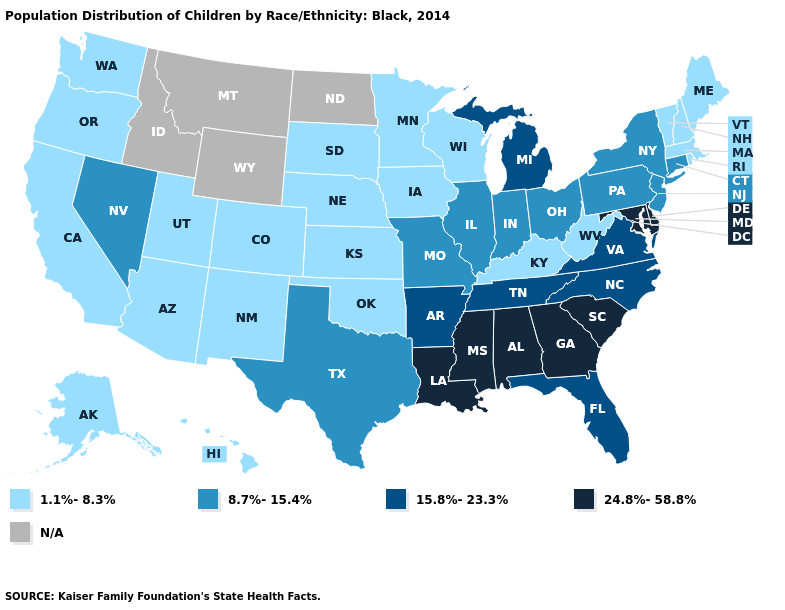Among the states that border Minnesota , which have the lowest value?
Be succinct. Iowa, South Dakota, Wisconsin. What is the value of Texas?
Be succinct. 8.7%-15.4%. Does Nebraska have the lowest value in the MidWest?
Give a very brief answer. Yes. Does North Carolina have the lowest value in the USA?
Quick response, please. No. Which states hav the highest value in the West?
Quick response, please. Nevada. Name the states that have a value in the range 1.1%-8.3%?
Write a very short answer. Alaska, Arizona, California, Colorado, Hawaii, Iowa, Kansas, Kentucky, Maine, Massachusetts, Minnesota, Nebraska, New Hampshire, New Mexico, Oklahoma, Oregon, Rhode Island, South Dakota, Utah, Vermont, Washington, West Virginia, Wisconsin. Which states have the highest value in the USA?
Short answer required. Alabama, Delaware, Georgia, Louisiana, Maryland, Mississippi, South Carolina. Name the states that have a value in the range 24.8%-58.8%?
Concise answer only. Alabama, Delaware, Georgia, Louisiana, Maryland, Mississippi, South Carolina. What is the lowest value in the USA?
Quick response, please. 1.1%-8.3%. What is the value of Florida?
Short answer required. 15.8%-23.3%. What is the value of South Carolina?
Answer briefly. 24.8%-58.8%. What is the value of Missouri?
Short answer required. 8.7%-15.4%. Which states hav the highest value in the South?
Concise answer only. Alabama, Delaware, Georgia, Louisiana, Maryland, Mississippi, South Carolina. 